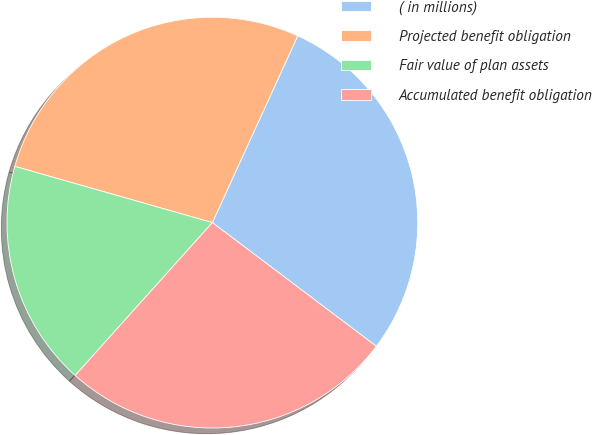Convert chart. <chart><loc_0><loc_0><loc_500><loc_500><pie_chart><fcel>( in millions)<fcel>Projected benefit obligation<fcel>Fair value of plan assets<fcel>Accumulated benefit obligation<nl><fcel>28.46%<fcel>27.41%<fcel>17.77%<fcel>26.36%<nl></chart> 